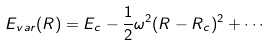<formula> <loc_0><loc_0><loc_500><loc_500>E _ { v a r } ( R ) = E _ { c } - \frac { 1 } { 2 } \omega ^ { 2 } ( R - R _ { c } ) ^ { 2 } + \cdots</formula> 